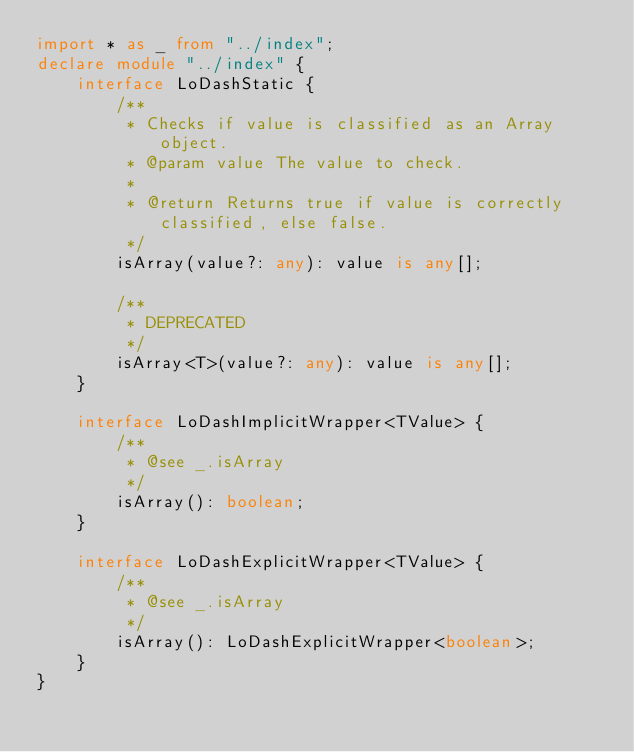Convert code to text. <code><loc_0><loc_0><loc_500><loc_500><_TypeScript_>import * as _ from "../index";
declare module "../index" {
    interface LoDashStatic {
        /**
         * Checks if value is classified as an Array object.
         * @param value The value to check.
         *
         * @return Returns true if value is correctly classified, else false.
         */
        isArray(value?: any): value is any[];

        /**
         * DEPRECATED
         */
        isArray<T>(value?: any): value is any[];
    }

    interface LoDashImplicitWrapper<TValue> {
        /**
         * @see _.isArray
         */
        isArray(): boolean;
    }

    interface LoDashExplicitWrapper<TValue> {
        /**
         * @see _.isArray
         */
        isArray(): LoDashExplicitWrapper<boolean>;
    }
}</code> 